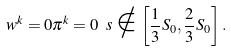Convert formula to latex. <formula><loc_0><loc_0><loc_500><loc_500>w ^ { k } = 0 \pi ^ { k } = 0 \ s \notin \left [ \frac { 1 } { 3 } S _ { 0 } , \frac { 2 } { 3 } S _ { 0 } \right ] .</formula> 